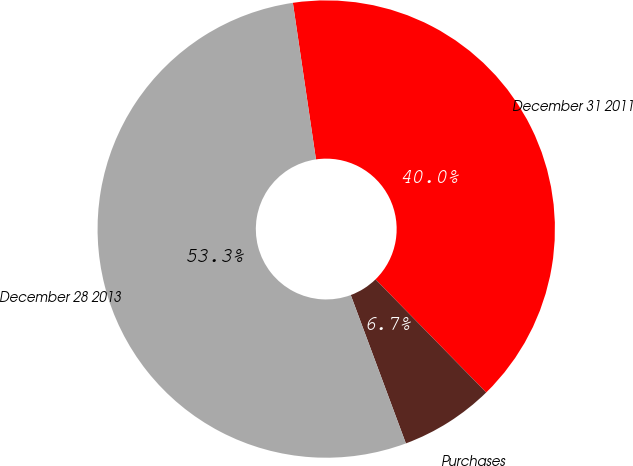Convert chart to OTSL. <chart><loc_0><loc_0><loc_500><loc_500><pie_chart><fcel>December 31 2011<fcel>Purchases<fcel>December 28 2013<nl><fcel>40.0%<fcel>6.67%<fcel>53.33%<nl></chart> 